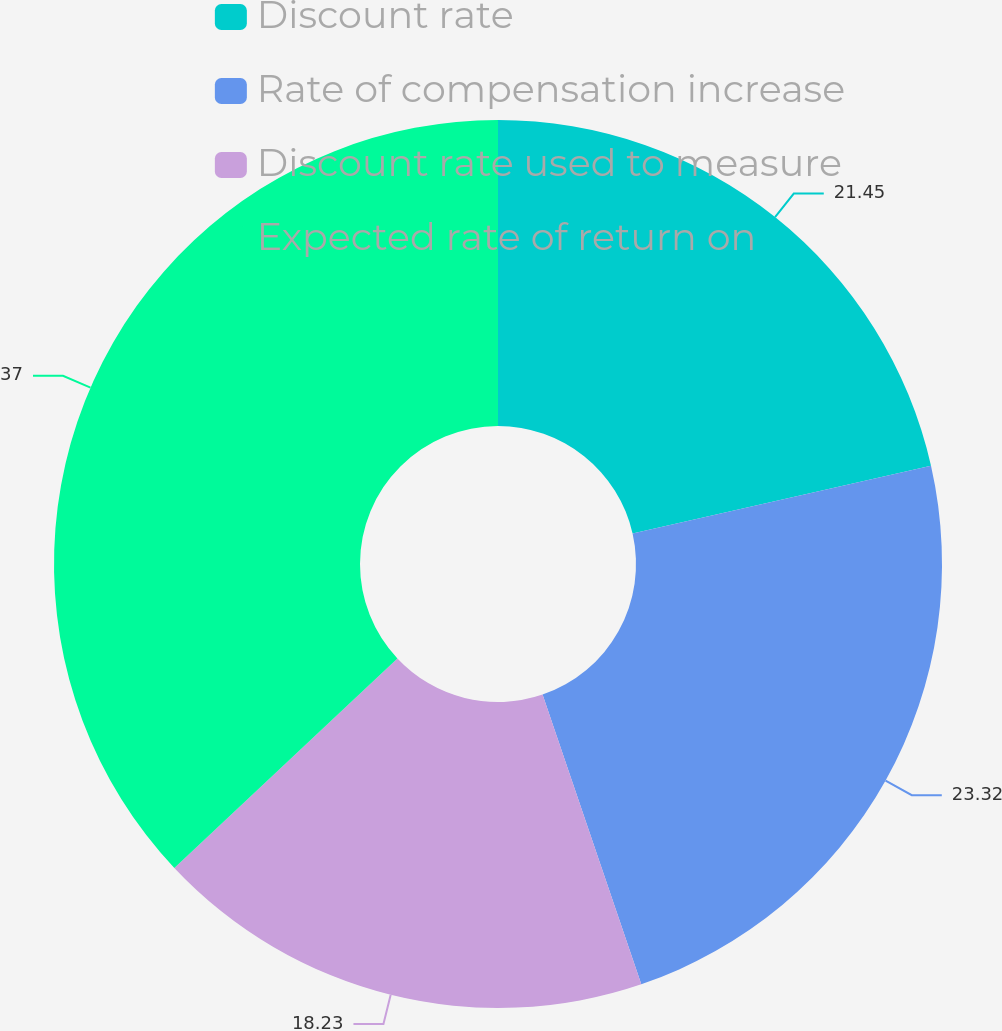<chart> <loc_0><loc_0><loc_500><loc_500><pie_chart><fcel>Discount rate<fcel>Rate of compensation increase<fcel>Discount rate used to measure<fcel>Expected rate of return on<nl><fcel>21.45%<fcel>23.32%<fcel>18.23%<fcel>37.0%<nl></chart> 